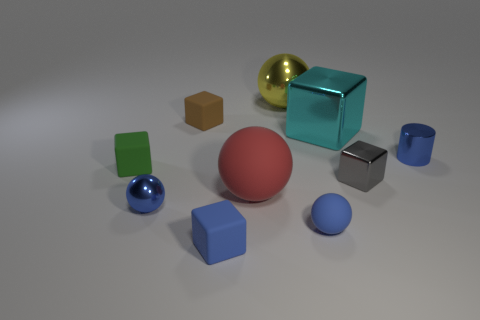Subtract all green blocks. How many blocks are left? 4 Subtract all cyan cubes. How many cubes are left? 4 Subtract 1 blocks. How many blocks are left? 4 Subtract all purple cubes. Subtract all yellow cylinders. How many cubes are left? 5 Subtract all spheres. How many objects are left? 6 Subtract 0 brown cylinders. How many objects are left? 10 Subtract all brown metal objects. Subtract all blue cubes. How many objects are left? 9 Add 7 large yellow metal things. How many large yellow metal things are left? 8 Add 8 large brown shiny spheres. How many large brown shiny spheres exist? 8 